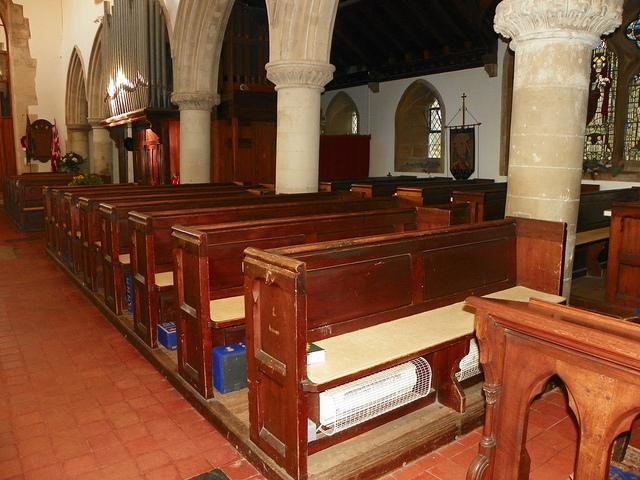What are the objects which are placed underneath the church pews?
Answer the question by selecting the correct answer among the 4 following choices and explain your choice with a short sentence. The answer should be formatted with the following format: `Answer: choice
Rationale: rationale.`
Options: Heaters, grates, storage boxes, lights. Answer: heaters.
Rationale: They are there to keep the people warm. 